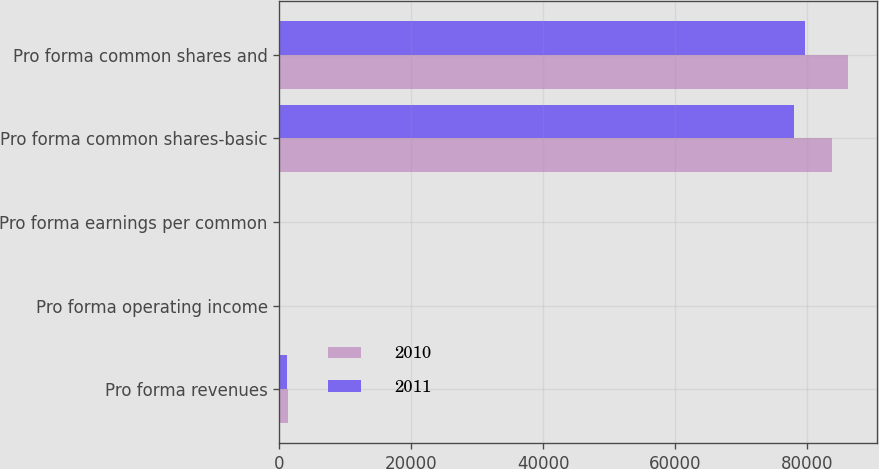Convert chart to OTSL. <chart><loc_0><loc_0><loc_500><loc_500><stacked_bar_chart><ecel><fcel>Pro forma revenues<fcel>Pro forma operating income<fcel>Pro forma earnings per common<fcel>Pro forma common shares-basic<fcel>Pro forma common shares and<nl><fcel>2010<fcel>1292.1<fcel>129<fcel>7.37<fcel>83762<fcel>86244<nl><fcel>2011<fcel>1210<fcel>135.4<fcel>3.65<fcel>78101<fcel>79761<nl></chart> 